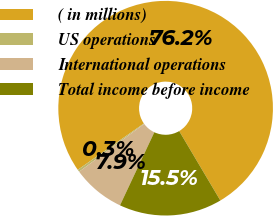Convert chart. <chart><loc_0><loc_0><loc_500><loc_500><pie_chart><fcel>( in millions)<fcel>US operations<fcel>International operations<fcel>Total income before income<nl><fcel>76.22%<fcel>0.34%<fcel>7.93%<fcel>15.51%<nl></chart> 